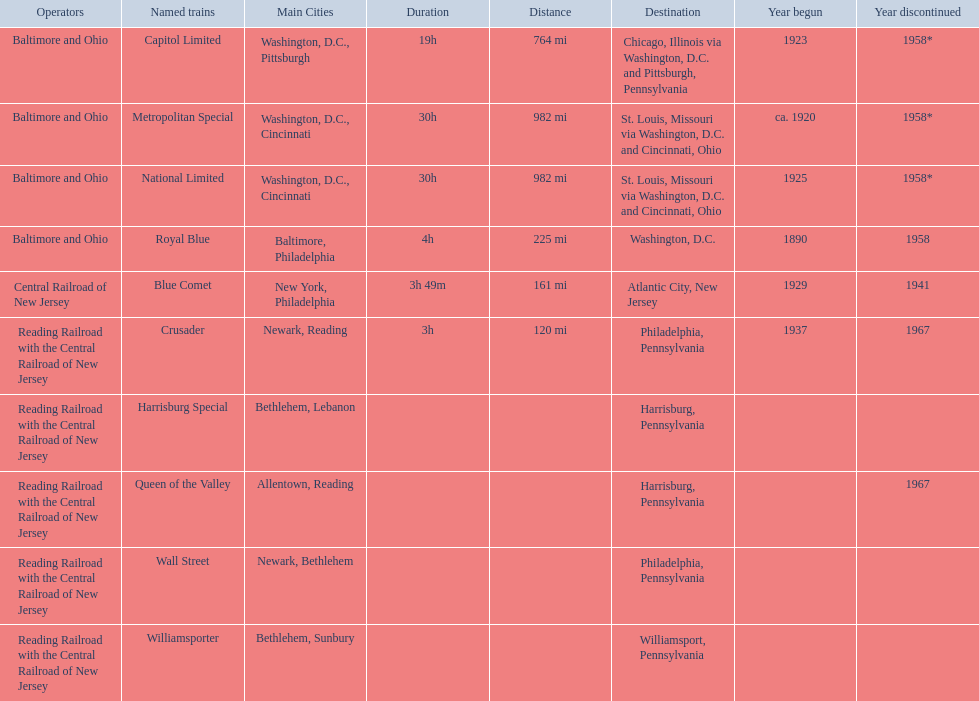What destinations are listed from the central railroad of new jersey terminal? Chicago, Illinois via Washington, D.C. and Pittsburgh, Pennsylvania, St. Louis, Missouri via Washington, D.C. and Cincinnati, Ohio, St. Louis, Missouri via Washington, D.C. and Cincinnati, Ohio, Washington, D.C., Atlantic City, New Jersey, Philadelphia, Pennsylvania, Harrisburg, Pennsylvania, Harrisburg, Pennsylvania, Philadelphia, Pennsylvania, Williamsport, Pennsylvania. Which of these destinations is listed first? Chicago, Illinois via Washington, D.C. and Pittsburgh, Pennsylvania. 